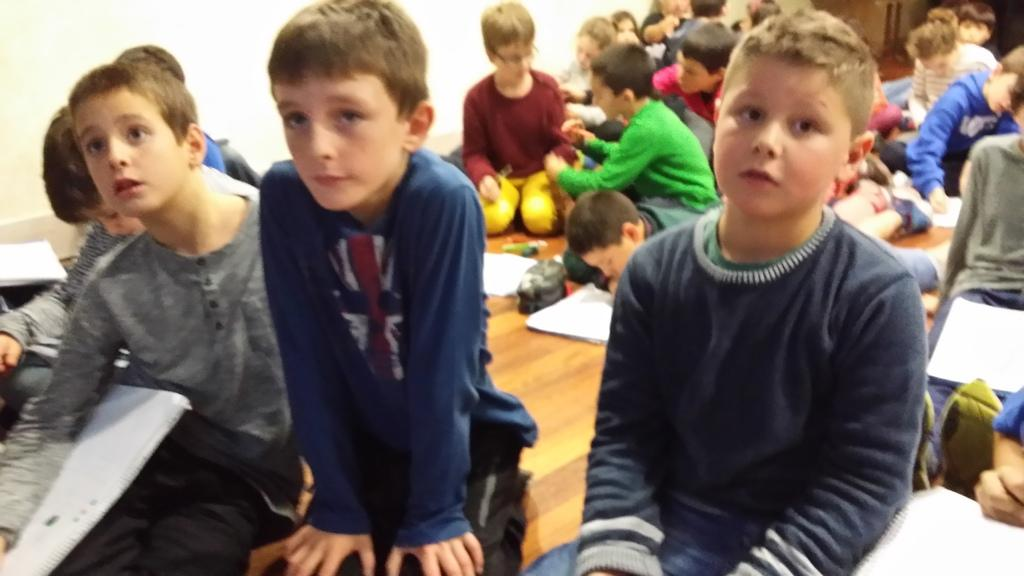What are the people in the image doing? There is a group of people sitting in the image. What can be seen in the background of the image? A: There is a wall in the background of the image. What items are visible in the image besides the people? There are books visible in the image. What is on the floor in the image? There are objects on the floor in the image. What type of cactus can be seen growing on the wall in the image? There is no cactus present in the image; the wall is in the background, but no plants are visible. 